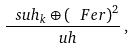Convert formula to latex. <formula><loc_0><loc_0><loc_500><loc_500>\frac { \ s u h _ { k } \oplus ( \ F e r ) ^ { 2 } } { \ u h } \, ,</formula> 